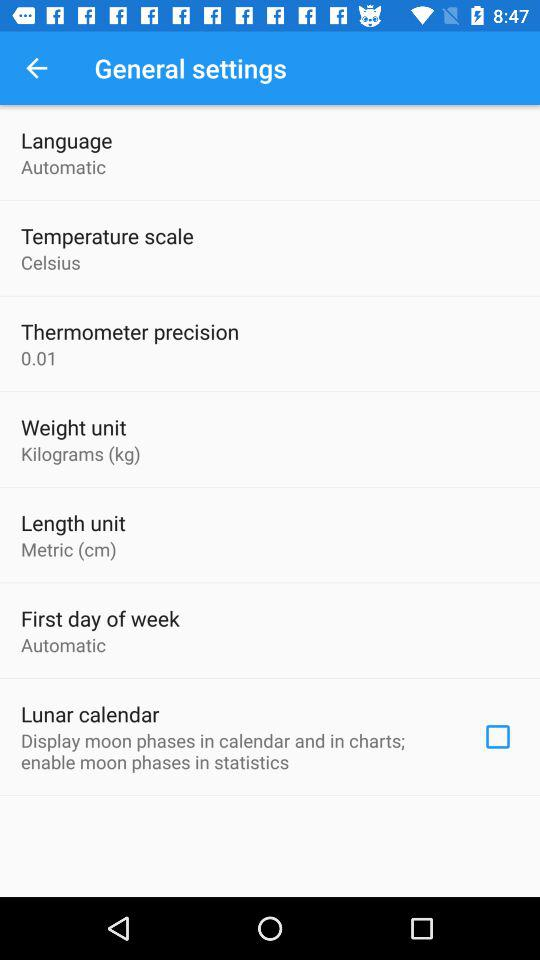What is the status of the lunar calendar? The status is off. 